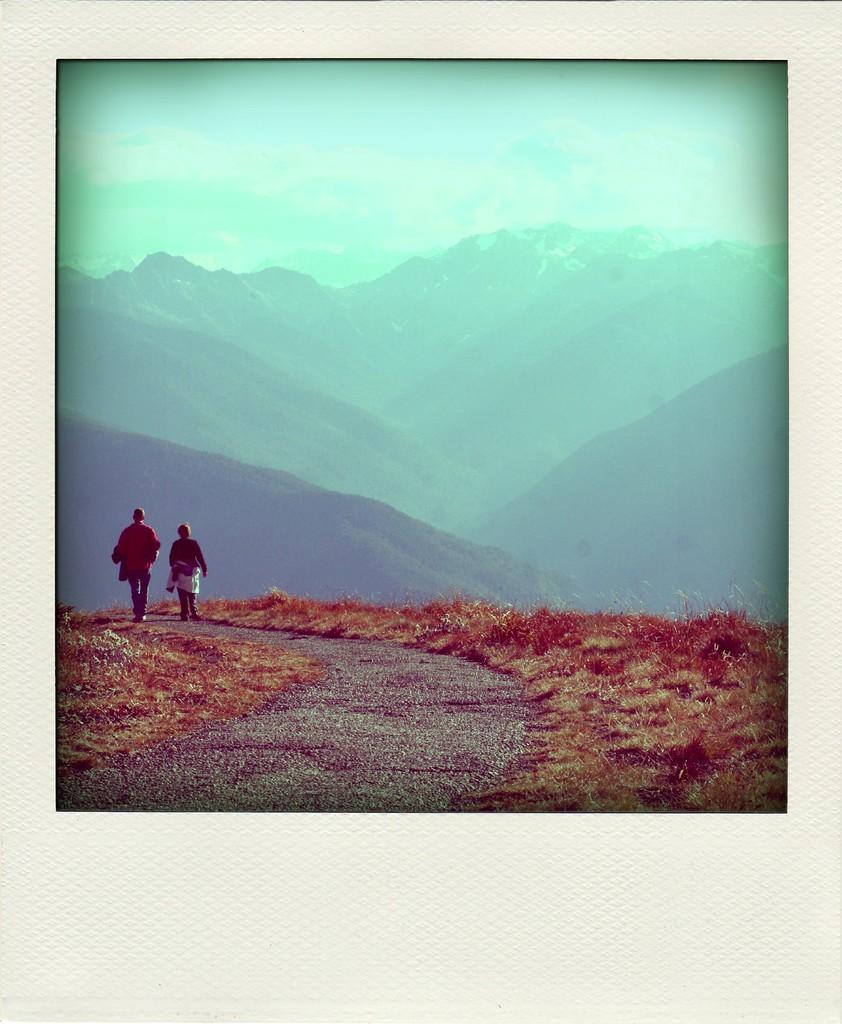Could you give a brief overview of what you see in this image? In this image there are two people walking on the road. At the bottom of the image there is grass on the surface. In the background of the image there are mountains. At the top of the image there are clouds in the sky. 